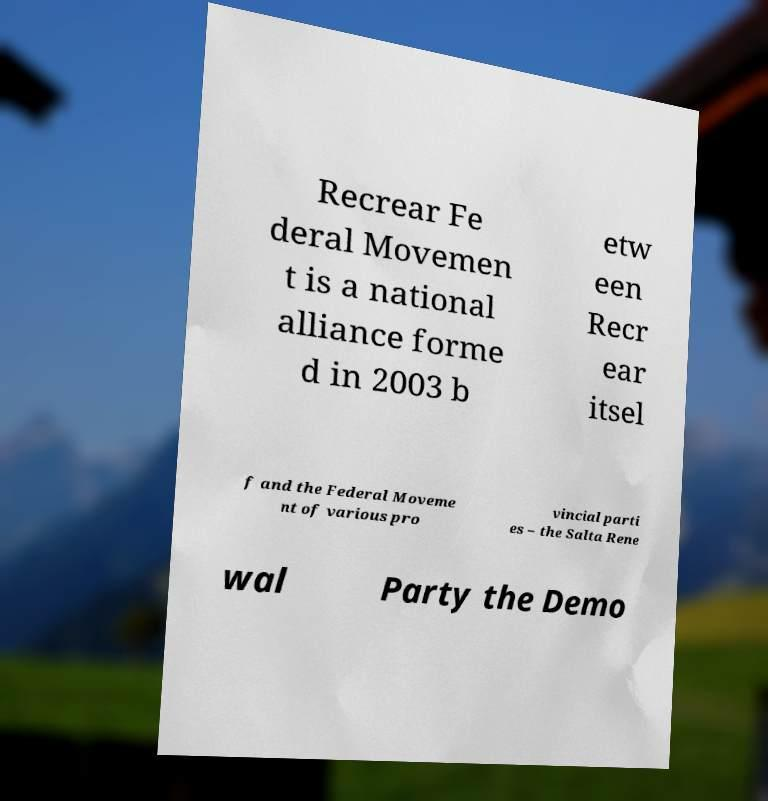Could you extract and type out the text from this image? Recrear Fe deral Movemen t is a national alliance forme d in 2003 b etw een Recr ear itsel f and the Federal Moveme nt of various pro vincial parti es – the Salta Rene wal Party the Demo 